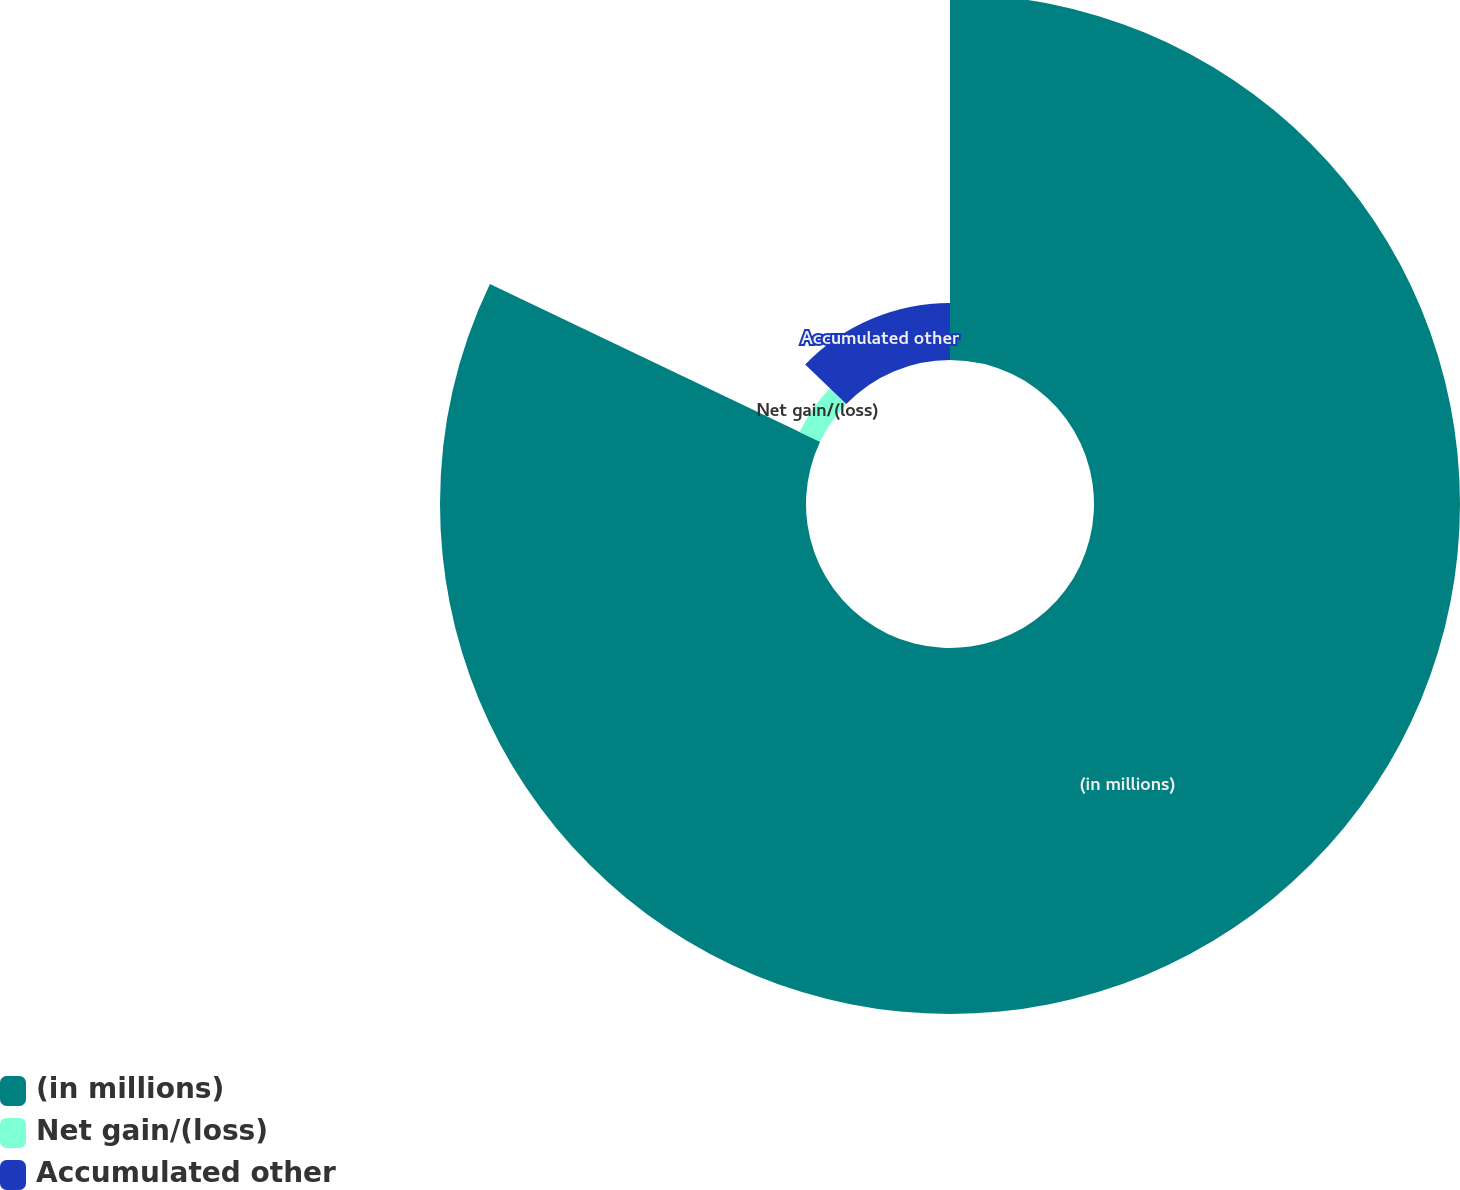<chart> <loc_0><loc_0><loc_500><loc_500><pie_chart><fcel>(in millions)<fcel>Net gain/(loss)<fcel>Accumulated other<nl><fcel>82.1%<fcel>5.1%<fcel>12.8%<nl></chart> 